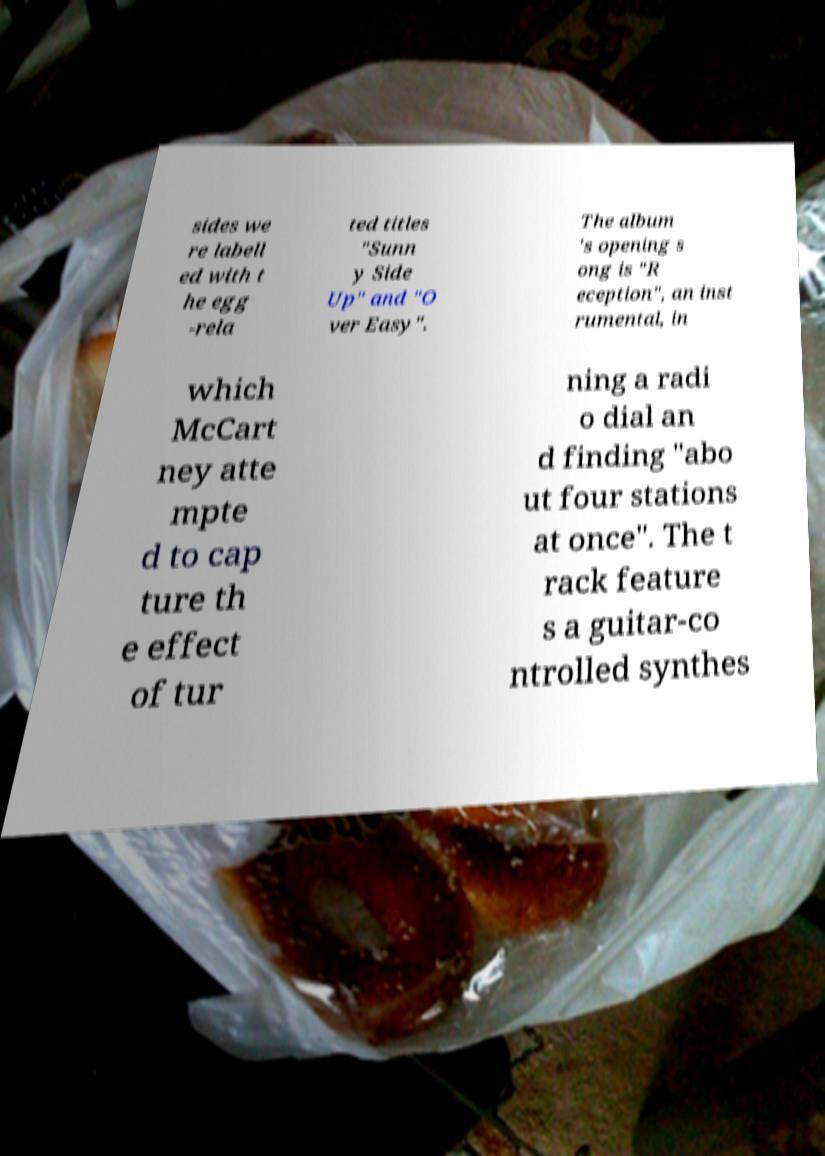Can you accurately transcribe the text from the provided image for me? sides we re labell ed with t he egg -rela ted titles "Sunn y Side Up" and "O ver Easy". The album 's opening s ong is "R eception", an inst rumental, in which McCart ney atte mpte d to cap ture th e effect of tur ning a radi o dial an d finding "abo ut four stations at once". The t rack feature s a guitar-co ntrolled synthes 